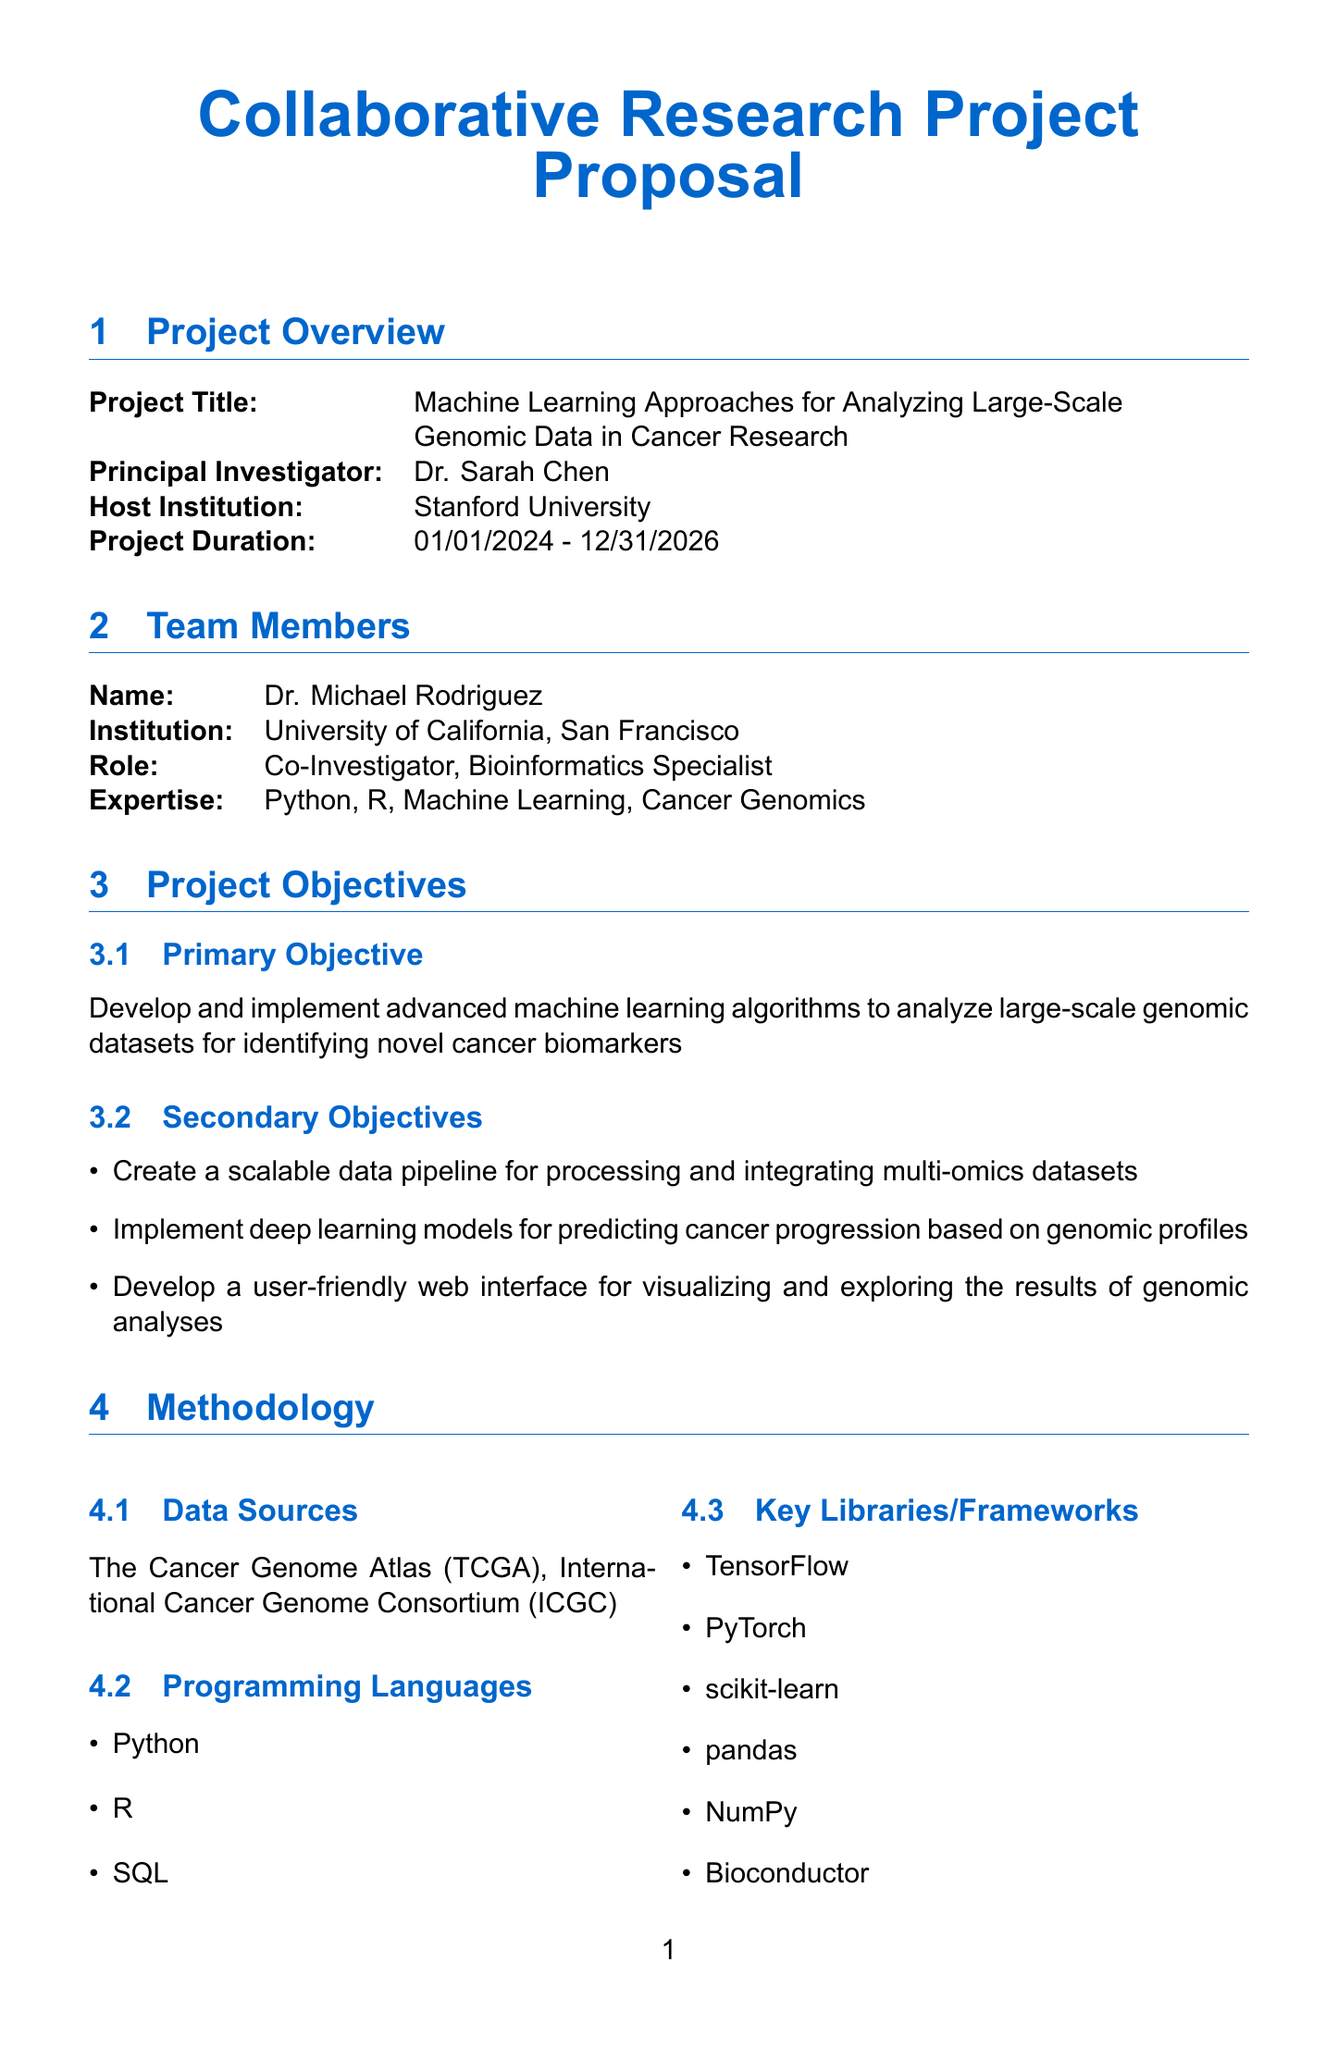What is the project title? The project title is clearly stated in the document's Project Overview section.
Answer: Machine Learning Approaches for Analyzing Large-Scale Genomic Data in Cancer Research Who is the Principal Investigator? The Principal Investigator's name is mentioned in the Project Overview section.
Answer: Dr. Sarah Chen What is the duration of the project? The project duration is specified in the Project Overview section as a date range.
Answer: 01/01/2024 - 12/31/2026 What is the primary objective of the project? The primary objective is outlined in the Project Objectives section, indicating the main goal of the research.
Answer: Develop and implement advanced machine learning algorithms to analyze large-scale genomic datasets for identifying novel cancer biomarkers Which institution is hosting the project? The host institution is detailed in the Project Overview section.
Answer: Stanford University What are the key libraries mentioned in the methodology? The key libraries for programming are listed under the Methodology section, showcasing essential tools.
Answer: TensorFlow, PyTorch, scikit-learn, pandas, NumPy, Bioconductor What is the communication tool used for collaboration? The collaboration plan specifies the communication tools in use for team interactions.
Answer: Slack How many peer-reviewed articles does the project aim to publish? The expected outcomes section specifies a target for publications, showcasing the research dissemination goal.
Answer: At least 3 peer-reviewed articles in high-impact journals What ethical approval has been obtained for the project? The document details the ethical considerations and approvals required for the research.
Answer: IRB approval obtained from Stanford University (Protocol #12345) What funding source is implied for the computational resources? The resource requirements outline the need for advanced computing resources necessary for the project.
Answer: Access to high-performance computing cluster with GPU capabilities 